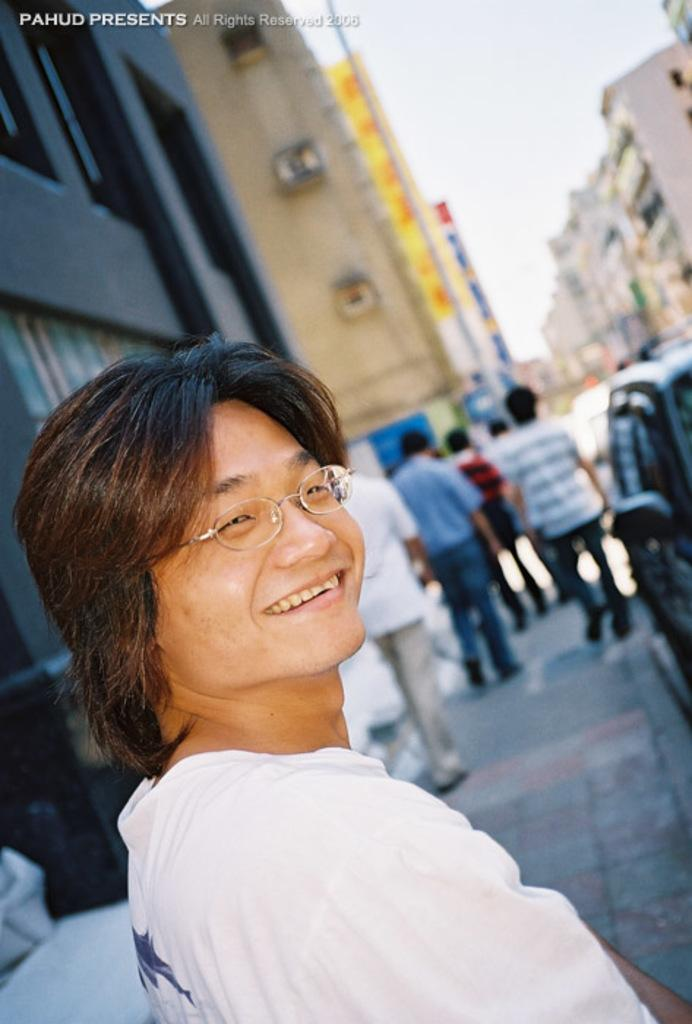What is the person in the image wearing? The person in the image is wearing spectacles. What are the people in the image doing? There is a group of people standing on the footpath in the image. What can be seen parked near the people? There is a car parked aside in the image. What type of structures are visible in the image? There are buildings visible in the image. What is present in the image besides the people and buildings? There is a pole in the image. What is visible in the background of the image? The sky is visible in the image. What type of rice is being cooked in the image? There is no rice present in the image; it features a person wearing spectacles and a group of people standing on the footpath. 